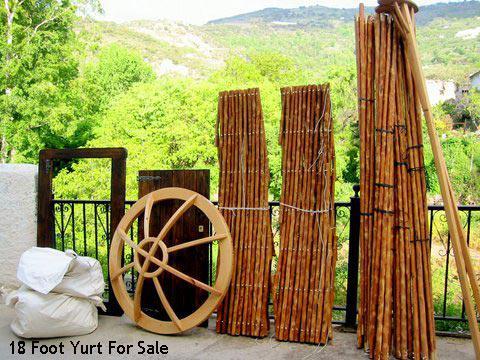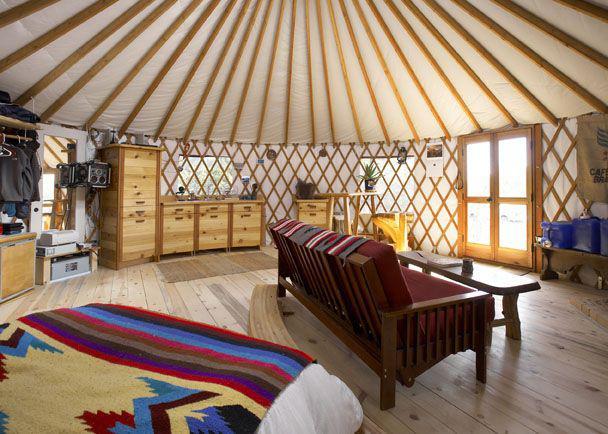The first image is the image on the left, the second image is the image on the right. Examine the images to the left and right. Is the description "Smoke is coming out of the chimney at the right side of a round building." accurate? Answer yes or no. No. The first image is the image on the left, the second image is the image on the right. For the images shown, is this caption "One of the images contains a cottage with smoke coming out of its chimney." true? Answer yes or no. No. 